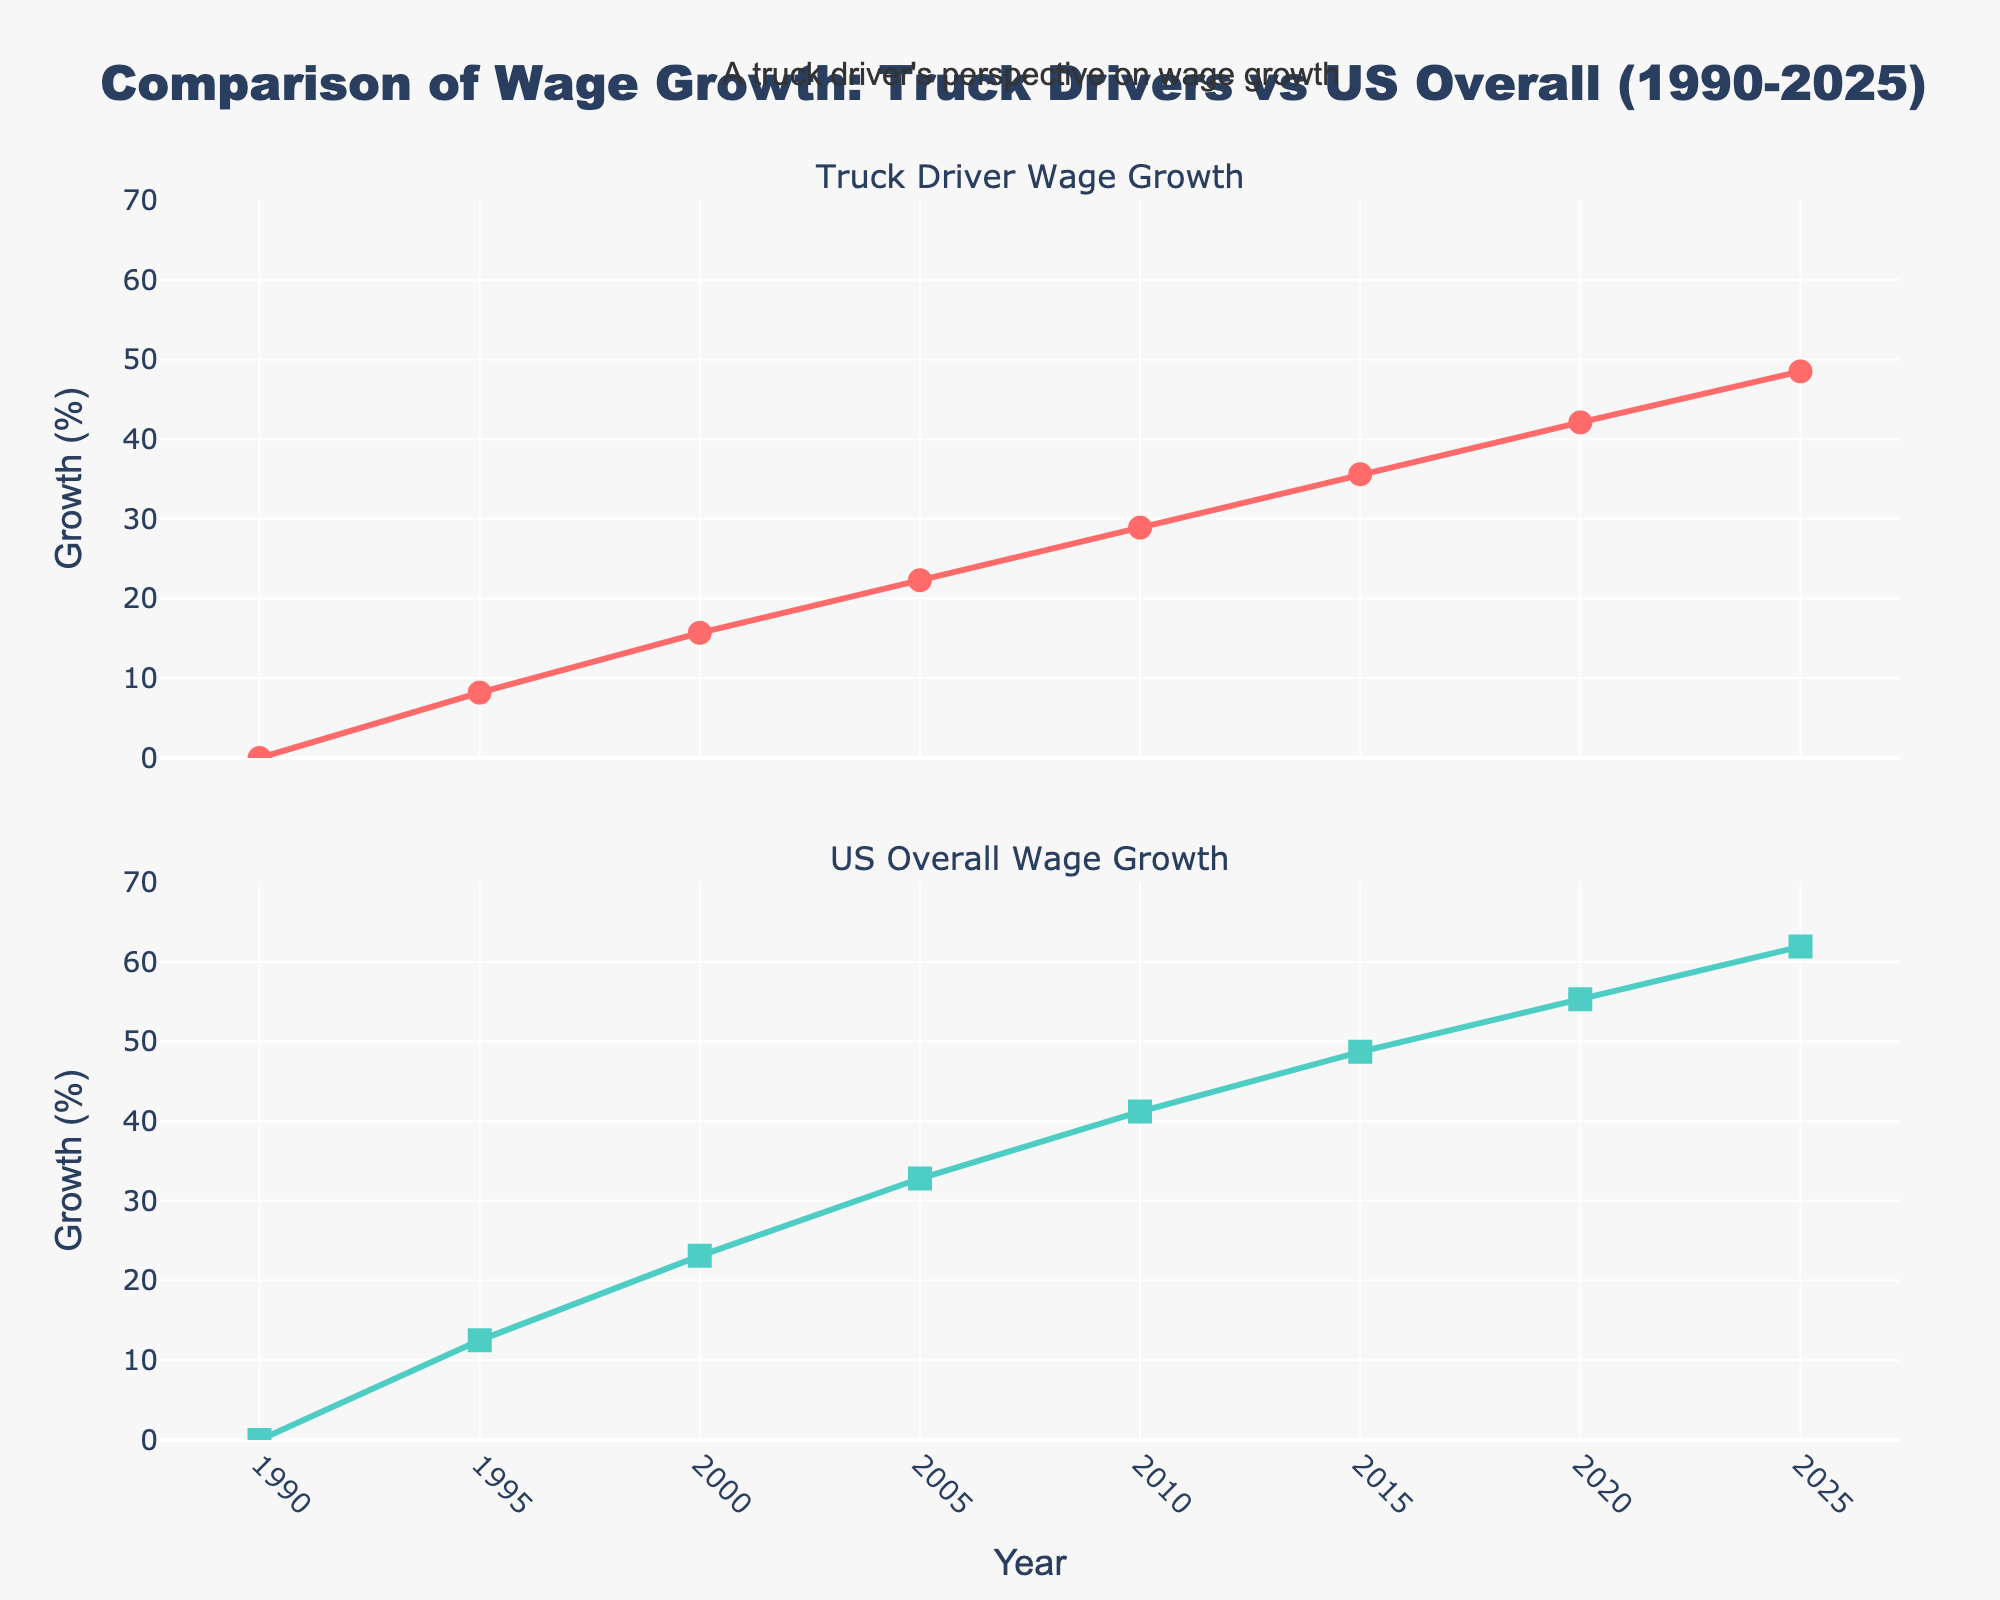What is the title of the figure? The title is located at the top of the figure and reads "Comparison of Wage Growth: Truck Drivers vs US Overall (1990-2025)".
Answer: "Comparison of Wage Growth: Truck Drivers vs US Overall (1990-2025)" How many data points are plotted for each line? Each subplot has data points marked for the years 1990, 1995, 2000, 2005, 2010, 2015, 2020, and 2025, totaling 8 data points.
Answer: 8 What is the range of the y-axis in both subplots? The y-axis ranges from 0% to 70%, with tick marks at every 10 percentage points.
Answer: 0% to 70% What color is used to plot the truck driver wage growth? The line for truck driver wage growth is colored red.
Answer: Red In which year did the US overall wage growth percentage exceed 20%? By identifying the points on the US overall wage growth line, the percentage first exceeds 20% in the year 2000.
Answer: 2000 Which wage growth (Truck Driver or US Overall) had a higher percentage in 2015? Comparing the data points for 2015, Truck Driver wage growth is 35.6% and US Overall wage growth is 48.7%. US Overall is higher.
Answer: US Overall By how much did the Truck Driver wage growth increase from 1990 to 2025? The Truck Driver wage growth increased from 0% in 1990 to 48.5% in 2025. The difference is 48.5% - 0% = 48.5%.
Answer: 48.5% Which subplot shows a trend where the growth percentage is always lower than the other subplot? By comparing the two subplots, the Truck Driver Wage Growth is consistently lower than the US Overall Wage Growth throughout the years.
Answer: Truck Driver Wage Growth What is the difference in US Overall Wage Growth between 1995 and 2000? The US Overall Wage Growth in 1995 is 12.5% and in 2000 is 23.1%. The difference is 23.1% - 12.5% = 10.6%.
Answer: 10.6% What is the shape of the markers used for the US Overall Wage Growth data points? The markers for the US Overall Wage Growth are in the shape of squares.
Answer: Squares 